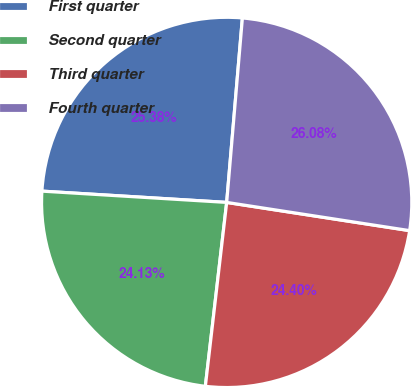Convert chart. <chart><loc_0><loc_0><loc_500><loc_500><pie_chart><fcel>First quarter<fcel>Second quarter<fcel>Third quarter<fcel>Fourth quarter<nl><fcel>25.38%<fcel>24.13%<fcel>24.4%<fcel>26.08%<nl></chart> 